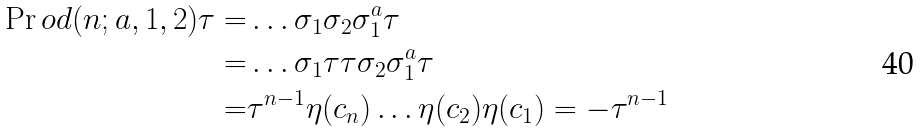Convert formula to latex. <formula><loc_0><loc_0><loc_500><loc_500>\Pr o d ( n ; a , 1 , 2 ) \tau = & \dots \sigma _ { 1 } \sigma _ { 2 } \sigma ^ { a } _ { 1 } \tau \\ = & \dots \sigma _ { 1 } \tau \tau \sigma _ { 2 } \sigma ^ { a } _ { 1 } \tau \\ = & \tau ^ { n - 1 } \eta ( c _ { n } ) \dots \eta ( c _ { 2 } ) \eta ( c _ { 1 } ) = - \tau ^ { n - 1 }</formula> 